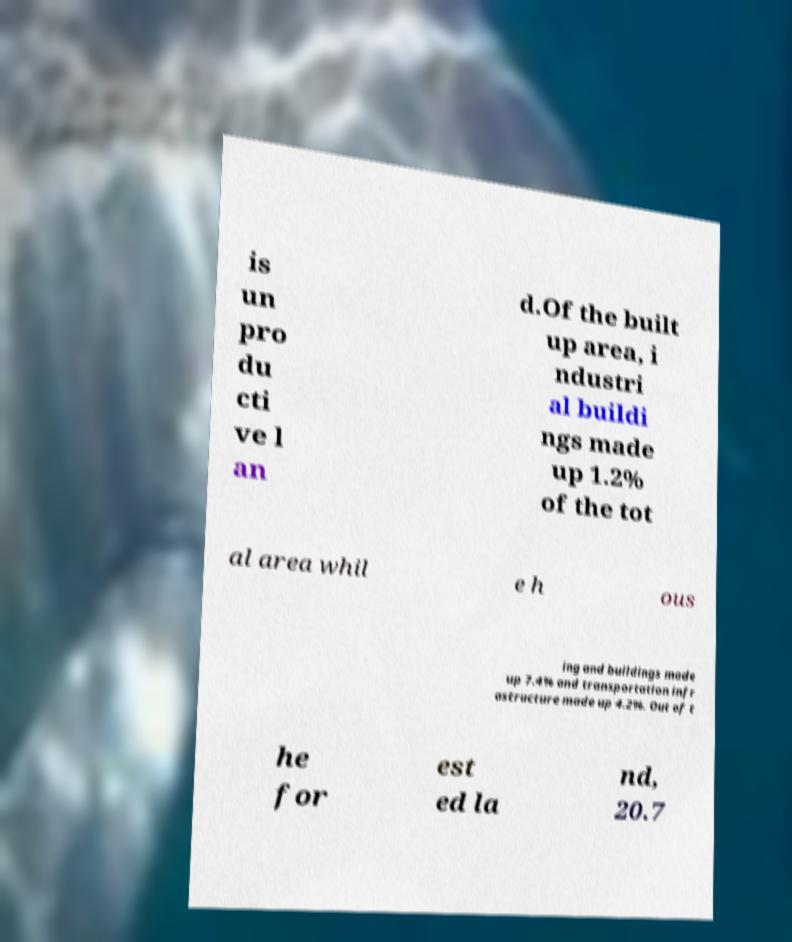Can you read and provide the text displayed in the image?This photo seems to have some interesting text. Can you extract and type it out for me? is un pro du cti ve l an d.Of the built up area, i ndustri al buildi ngs made up 1.2% of the tot al area whil e h ous ing and buildings made up 7.4% and transportation infr astructure made up 4.2%. Out of t he for est ed la nd, 20.7 